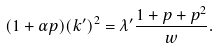<formula> <loc_0><loc_0><loc_500><loc_500>( 1 + \alpha p ) ( k ^ { \prime } ) ^ { 2 } = \lambda ^ { \prime } \frac { 1 + p + p ^ { 2 } } { w } .</formula> 